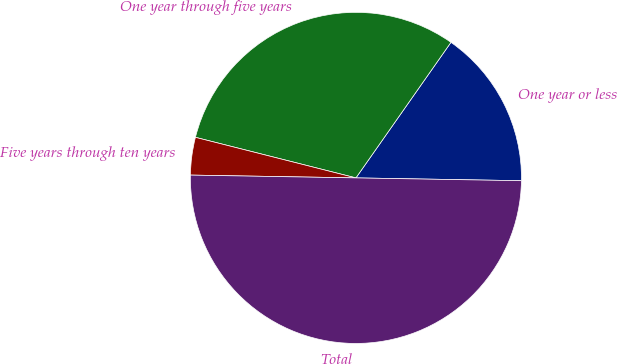<chart> <loc_0><loc_0><loc_500><loc_500><pie_chart><fcel>One year or less<fcel>One year through five years<fcel>Five years through ten years<fcel>Total<nl><fcel>15.54%<fcel>30.79%<fcel>3.67%<fcel>50.0%<nl></chart> 